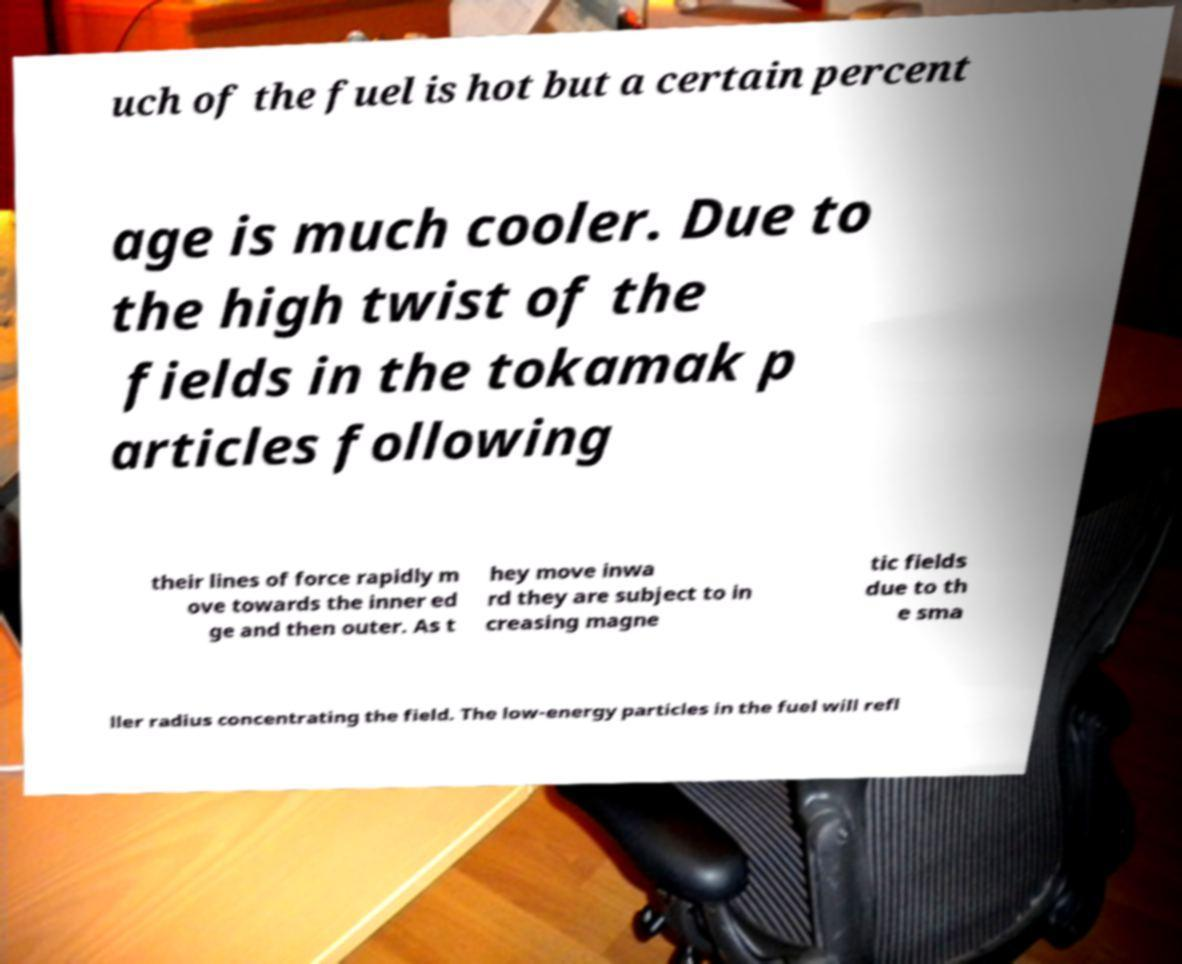Could you extract and type out the text from this image? uch of the fuel is hot but a certain percent age is much cooler. Due to the high twist of the fields in the tokamak p articles following their lines of force rapidly m ove towards the inner ed ge and then outer. As t hey move inwa rd they are subject to in creasing magne tic fields due to th e sma ller radius concentrating the field. The low-energy particles in the fuel will refl 